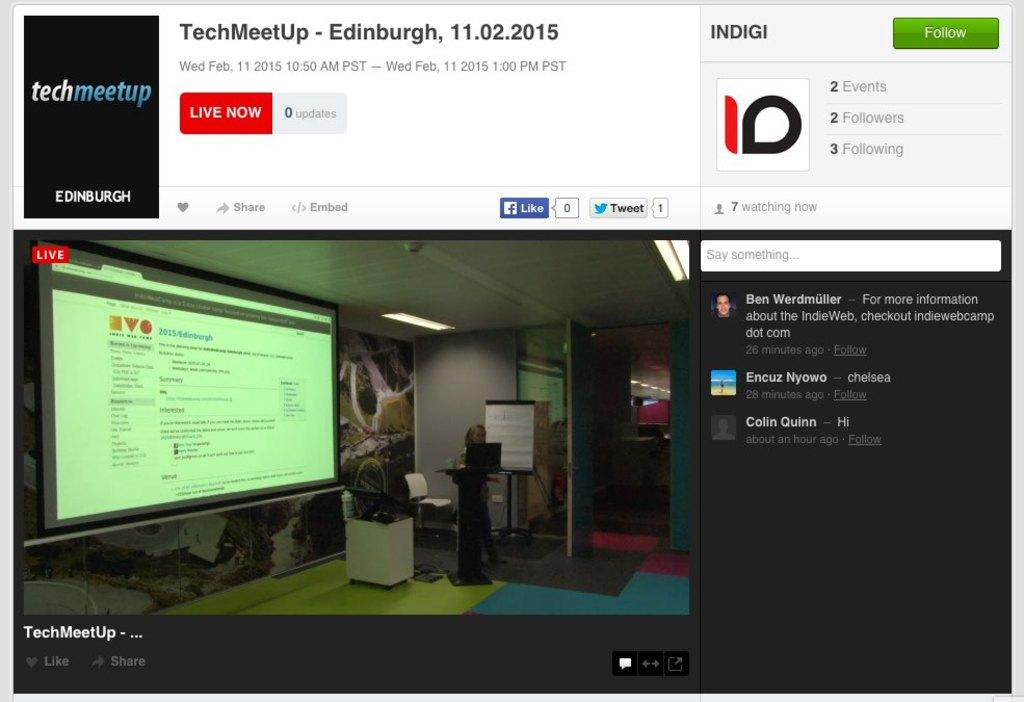Provide a one-sentence caption for the provided image. A webinar for TechMeet Up is shown as being Live. 